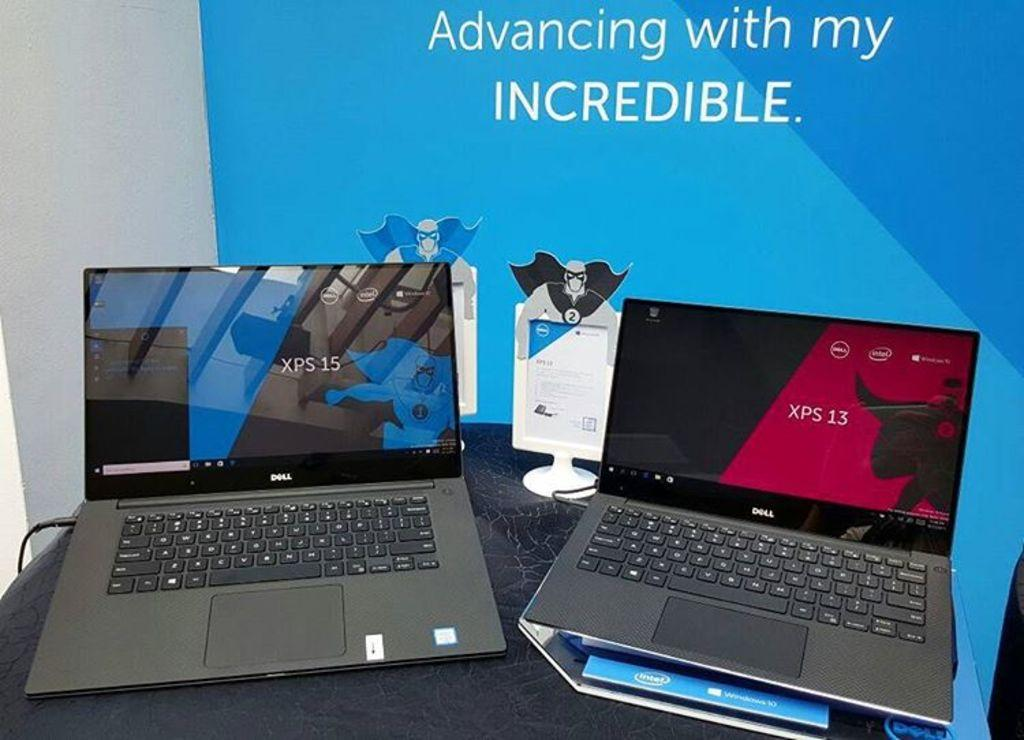<image>
Summarize the visual content of the image. Two Dell laptops sit on a desk in front of a banner that says "Advancing with my INCREDIBLE" 